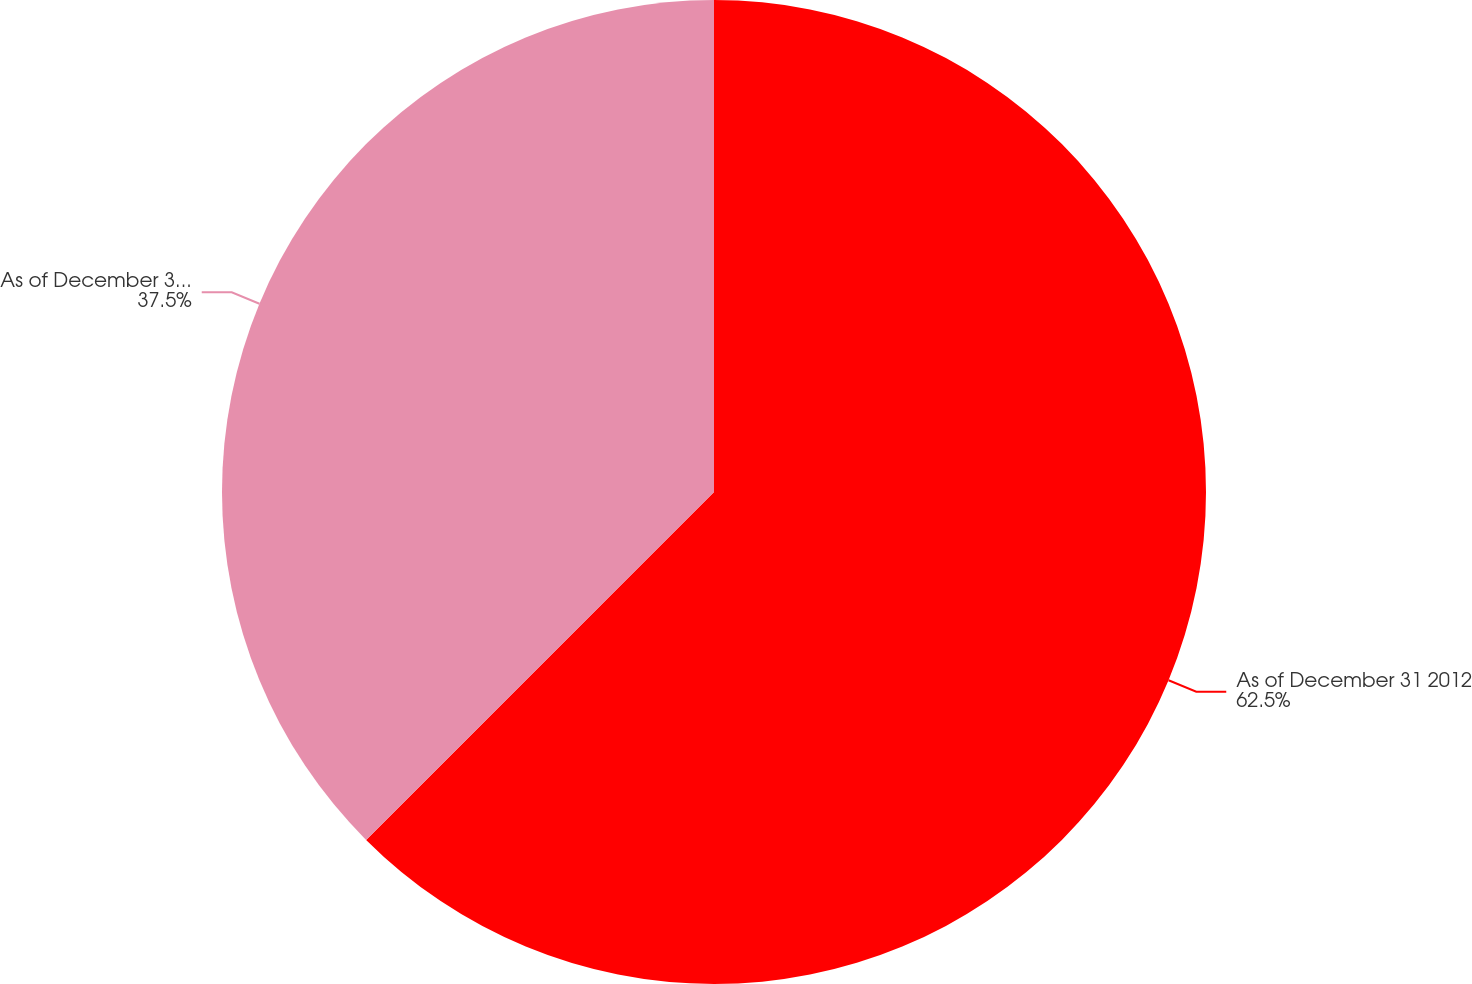Convert chart to OTSL. <chart><loc_0><loc_0><loc_500><loc_500><pie_chart><fcel>As of December 31 2012<fcel>As of December 31 2011<nl><fcel>62.5%<fcel>37.5%<nl></chart> 